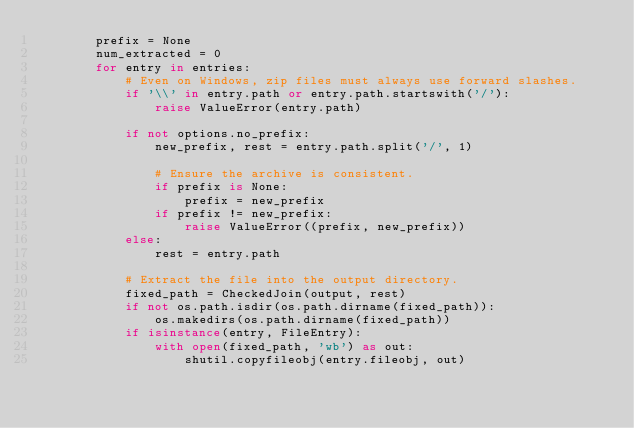<code> <loc_0><loc_0><loc_500><loc_500><_Python_>        prefix = None
        num_extracted = 0
        for entry in entries:
            # Even on Windows, zip files must always use forward slashes.
            if '\\' in entry.path or entry.path.startswith('/'):
                raise ValueError(entry.path)

            if not options.no_prefix:
                new_prefix, rest = entry.path.split('/', 1)

                # Ensure the archive is consistent.
                if prefix is None:
                    prefix = new_prefix
                if prefix != new_prefix:
                    raise ValueError((prefix, new_prefix))
            else:
                rest = entry.path

            # Extract the file into the output directory.
            fixed_path = CheckedJoin(output, rest)
            if not os.path.isdir(os.path.dirname(fixed_path)):
                os.makedirs(os.path.dirname(fixed_path))
            if isinstance(entry, FileEntry):
                with open(fixed_path, 'wb') as out:
                    shutil.copyfileobj(entry.fileobj, out)</code> 